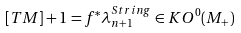Convert formula to latex. <formula><loc_0><loc_0><loc_500><loc_500>[ T M ] + 1 = f ^ { * } \lambda ^ { S t r i n g } _ { n + 1 } \in K O ^ { 0 } ( M _ { + } )</formula> 